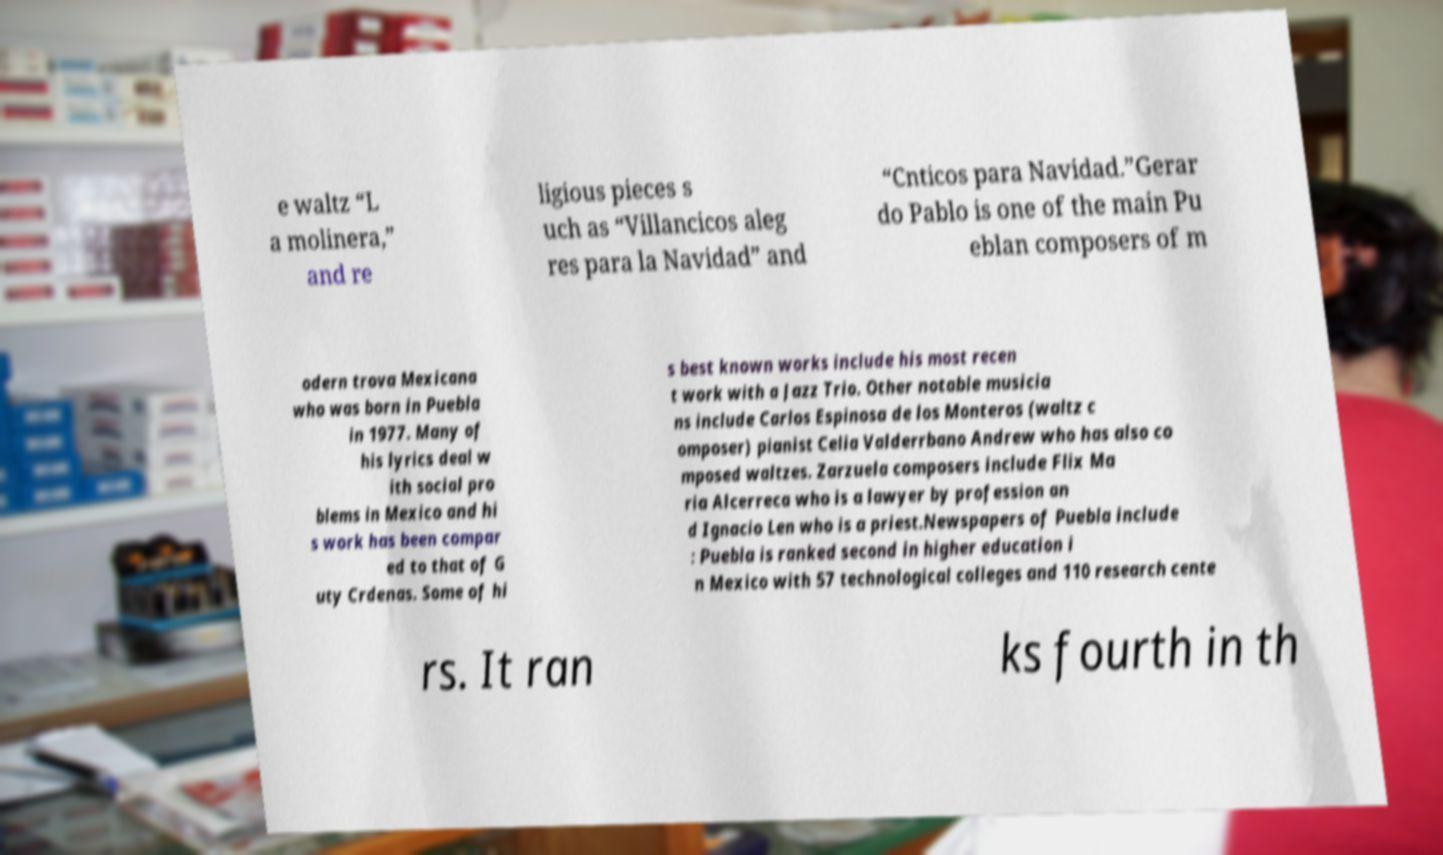Could you extract and type out the text from this image? e waltz “L a molinera,” and re ligious pieces s uch as “Villancicos aleg res para la Navidad” and “Cnticos para Navidad.”Gerar do Pablo is one of the main Pu eblan composers of m odern trova Mexicana who was born in Puebla in 1977. Many of his lyrics deal w ith social pro blems in Mexico and hi s work has been compar ed to that of G uty Crdenas. Some of hi s best known works include his most recen t work with a Jazz Trio. Other notable musicia ns include Carlos Espinosa de los Monteros (waltz c omposer) pianist Celia Valderrbano Andrew who has also co mposed waltzes. Zarzuela composers include Flix Ma ria Alcerreca who is a lawyer by profession an d Ignacio Len who is a priest.Newspapers of Puebla include : Puebla is ranked second in higher education i n Mexico with 57 technological colleges and 110 research cente rs. It ran ks fourth in th 